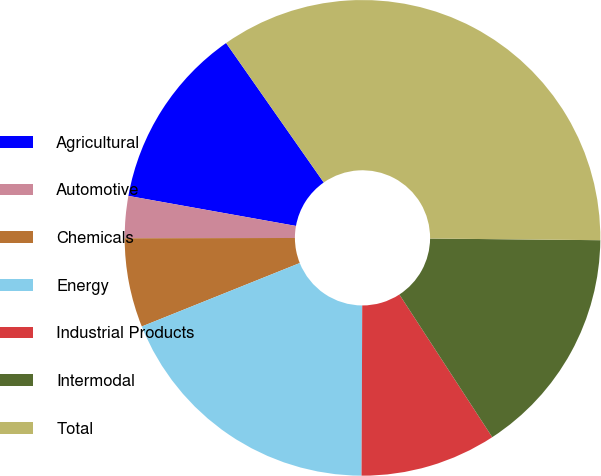Convert chart. <chart><loc_0><loc_0><loc_500><loc_500><pie_chart><fcel>Agricultural<fcel>Automotive<fcel>Chemicals<fcel>Energy<fcel>Industrial Products<fcel>Intermodal<fcel>Total<nl><fcel>12.46%<fcel>2.85%<fcel>6.05%<fcel>18.86%<fcel>9.25%<fcel>15.66%<fcel>34.88%<nl></chart> 